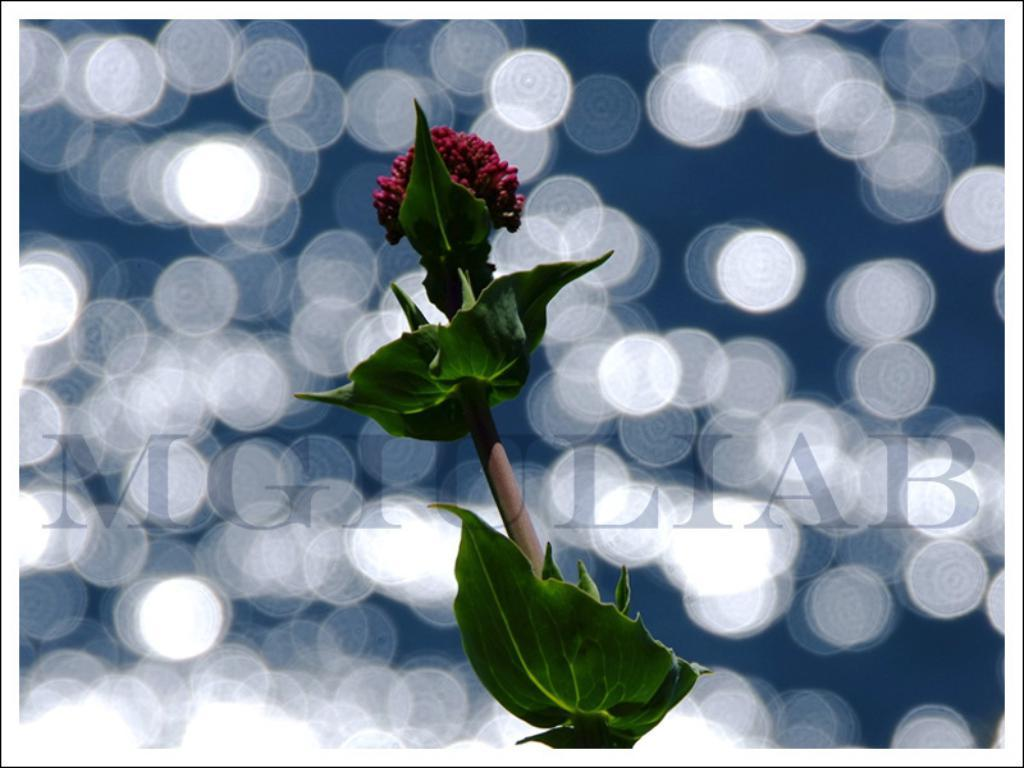What is the main subject of the image? The main subject of the image is a flower. What can be observed about the flower's structure? The flower has leaves. Can you describe the background of the image? The background of the image is blurry. How is the hole in the flower being used in the image? There is no hole present in the flower in the image. What type of glue is being used to attach the flower to the van in the image? There is no van or glue present in the image; it only features a flower with leaves and a blurry background. 